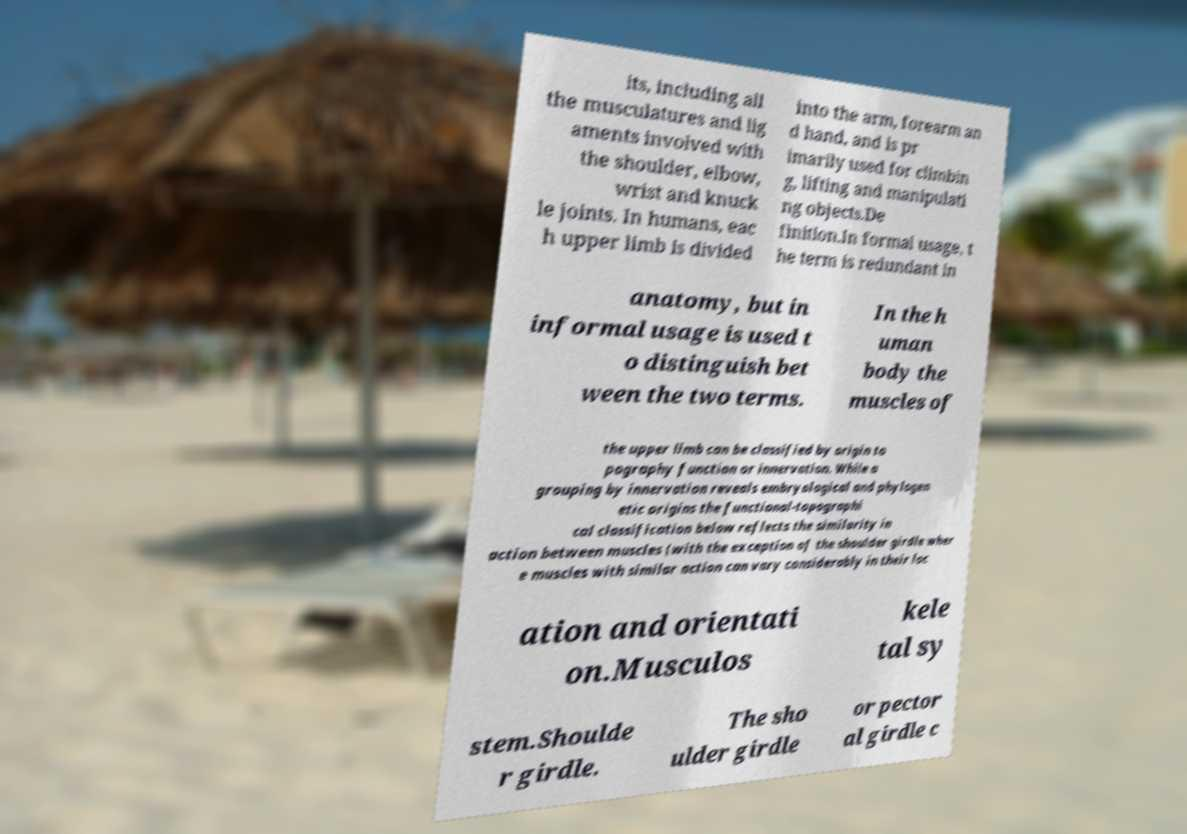What messages or text are displayed in this image? I need them in a readable, typed format. its, including all the musculatures and lig aments involved with the shoulder, elbow, wrist and knuck le joints. In humans, eac h upper limb is divided into the arm, forearm an d hand, and is pr imarily used for climbin g, lifting and manipulati ng objects.De finition.In formal usage, t he term is redundant in anatomy, but in informal usage is used t o distinguish bet ween the two terms. In the h uman body the muscles of the upper limb can be classified by origin to pography function or innervation. While a grouping by innervation reveals embryological and phylogen etic origins the functional-topographi cal classification below reflects the similarity in action between muscles (with the exception of the shoulder girdle wher e muscles with similar action can vary considerably in their loc ation and orientati on.Musculos kele tal sy stem.Shoulde r girdle. The sho ulder girdle or pector al girdle c 